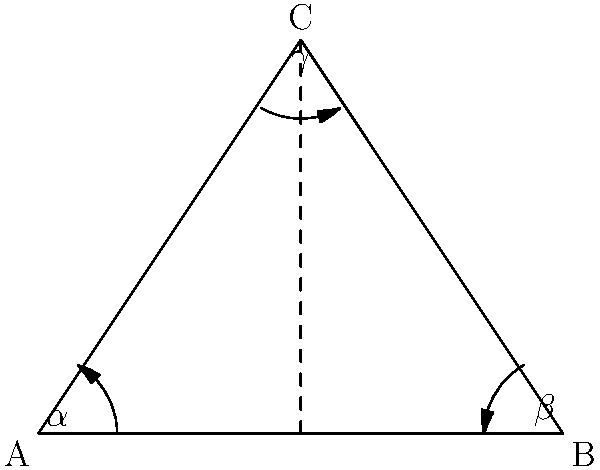In hyperbolic geometry, the sum of the angles in a triangle is always less than 180°. Consider a hyperbolic triangle ABC with angles $\alpha$, $\beta$, and $\gamma$. If the area of this triangle is $k$ times the area of an ideal triangle (a triangle with all vertices at infinity) in the same hyperbolic plane, express the sum of the angles $\alpha + \beta + \gamma$ in terms of $k$ and $\pi$. Let's approach this step-by-step:

1) In hyperbolic geometry, the area of a triangle is directly related to its angle defect. The angle defect is the difference between $\pi$ (180°) and the sum of the triangle's angles.

2) The area $A$ of a hyperbolic triangle is given by the formula:

   $$A = \pi - (\alpha + \beta + \gamma)$$

3) An ideal triangle in hyperbolic geometry has an area of $\pi$. This is a constant regardless of the hyperbolic plane.

4) We're told that the area of our triangle is $k$ times the area of an ideal triangle. So:

   $$A = k\pi$$

5) Equating these two expressions for the area:

   $$k\pi = \pi - (\alpha + \beta + \gamma)$$

6) Solving for the sum of the angles:

   $$\alpha + \beta + \gamma = \pi - k\pi = \pi(1-k)$$

This formula relates the sum of the angles to $k$ and $\pi$, as required.
Answer: $\pi(1-k)$ 